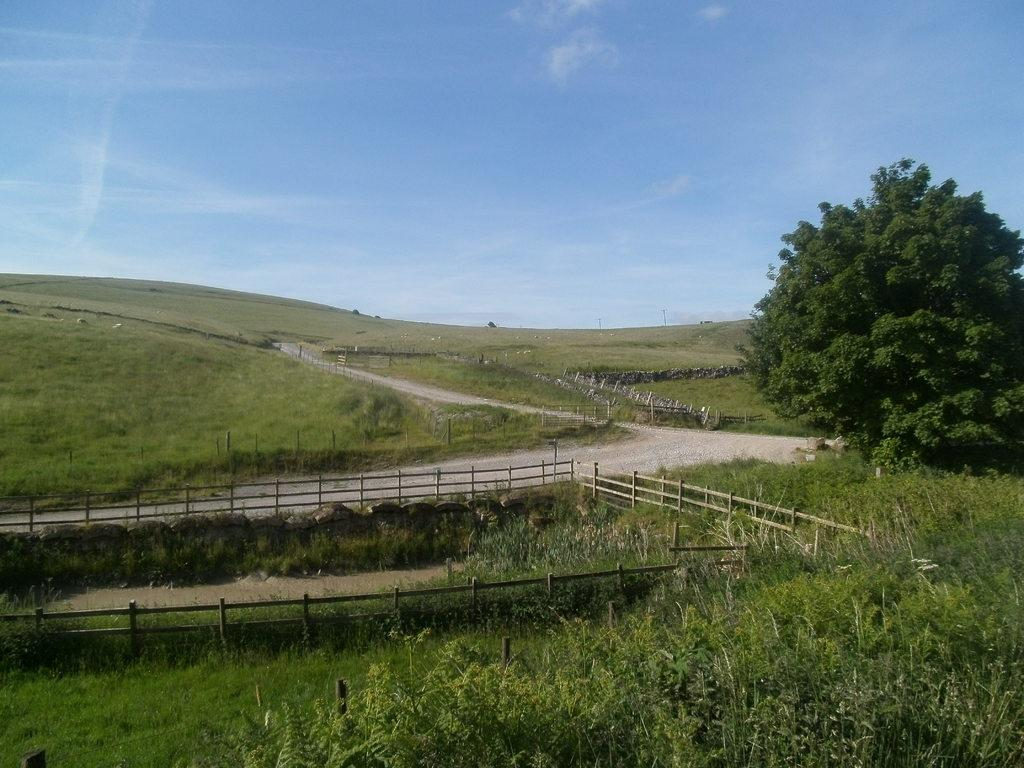What type of surface can be seen in the image? There is ground visible in the image. What is present on the ground? There are objects on the ground. What type of vegetation is in the image? There is grass, plants, and trees in the image. What is the boundary in the image? There is a fence in the image. What is visible above the ground? The sky is visible in the image. What can be seen in the sky? There are clouds in the sky. What type of jar is being used to spy on the plants in the image? There is no jar or spying activity present in the image. 